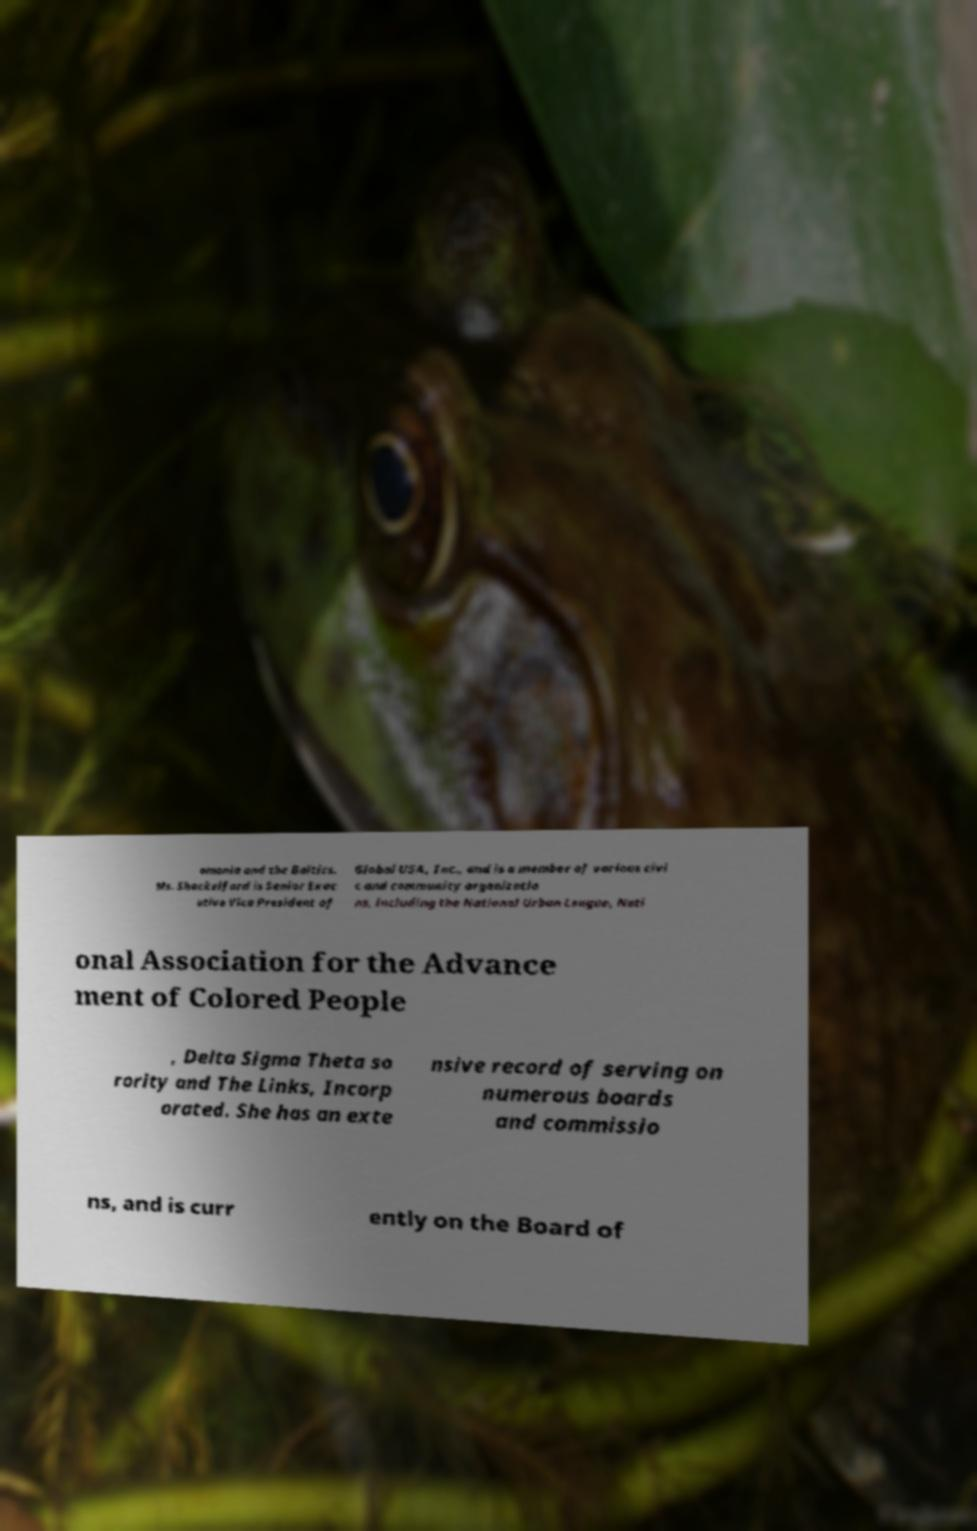For documentation purposes, I need the text within this image transcribed. Could you provide that? omania and the Baltics. Ms. Shackelford is Senior Exec utive Vice President of Global USA, Inc., and is a member of various civi c and community organizatio ns, including the National Urban League, Nati onal Association for the Advance ment of Colored People , Delta Sigma Theta so rority and The Links, Incorp orated. She has an exte nsive record of serving on numerous boards and commissio ns, and is curr ently on the Board of 